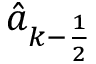Convert formula to latex. <formula><loc_0><loc_0><loc_500><loc_500>\hat { a } _ { k - \frac { 1 } { 2 } }</formula> 